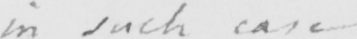Can you tell me what this handwritten text says? in such case 